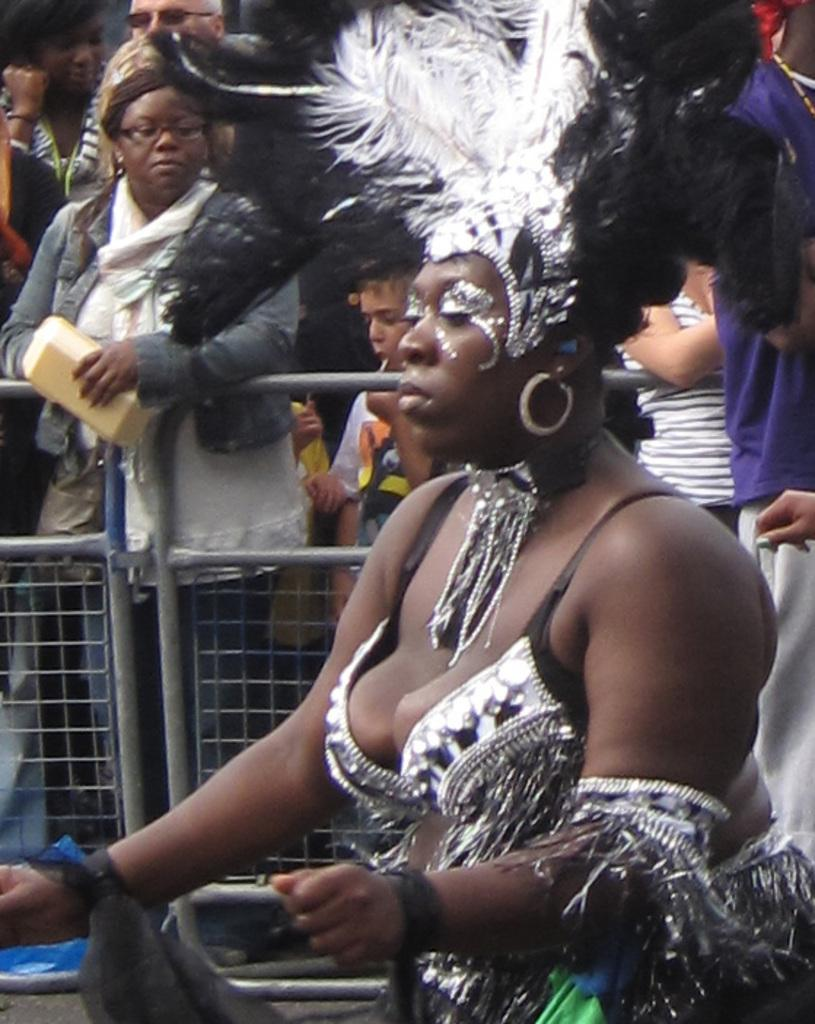What is the main subject in the foreground of the image? There is a woman in the foreground of the image. Can you describe the background of the image? There are other people and a boundary visible in the background of the image. What type of noise can be heard coming from the ground in the image? There is no reference to noise or the ground in the image, so it's not possible to determine what, if any, noise might be heard. 